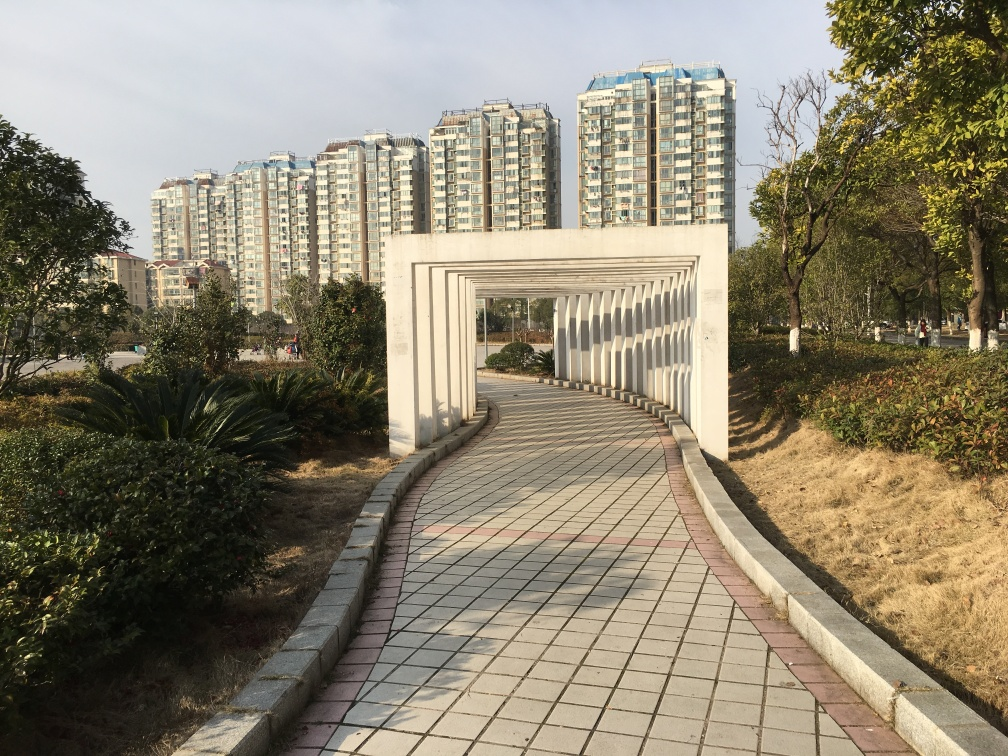How would you describe the atmosphere of this location? The location exudes a calm and orderly atmosphere, typical of a well-maintained urban park. The open path invites pedestrians for a stroll, while the modern apartments in the distance suggest a vibrant community living nearby. 